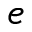Convert formula to latex. <formula><loc_0><loc_0><loc_500><loc_500>e</formula> 